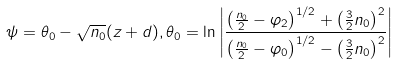Convert formula to latex. <formula><loc_0><loc_0><loc_500><loc_500>\psi = \theta _ { 0 } - \sqrt { n _ { 0 } } ( z + d ) , \theta _ { 0 } = \ln \left | \frac { \left ( \frac { n _ { 0 } } { 2 } - \varphi _ { 2 } \right ) ^ { 1 / 2 } + \left ( \frac { 3 } { 2 } n _ { 0 } \right ) ^ { 2 } } { \left ( \frac { n _ { 0 } } { 2 } - \varphi _ { 0 } \right ) ^ { 1 / 2 } - \left ( \frac { 3 } { 2 } n _ { 0 } \right ) ^ { 2 } } \right |</formula> 